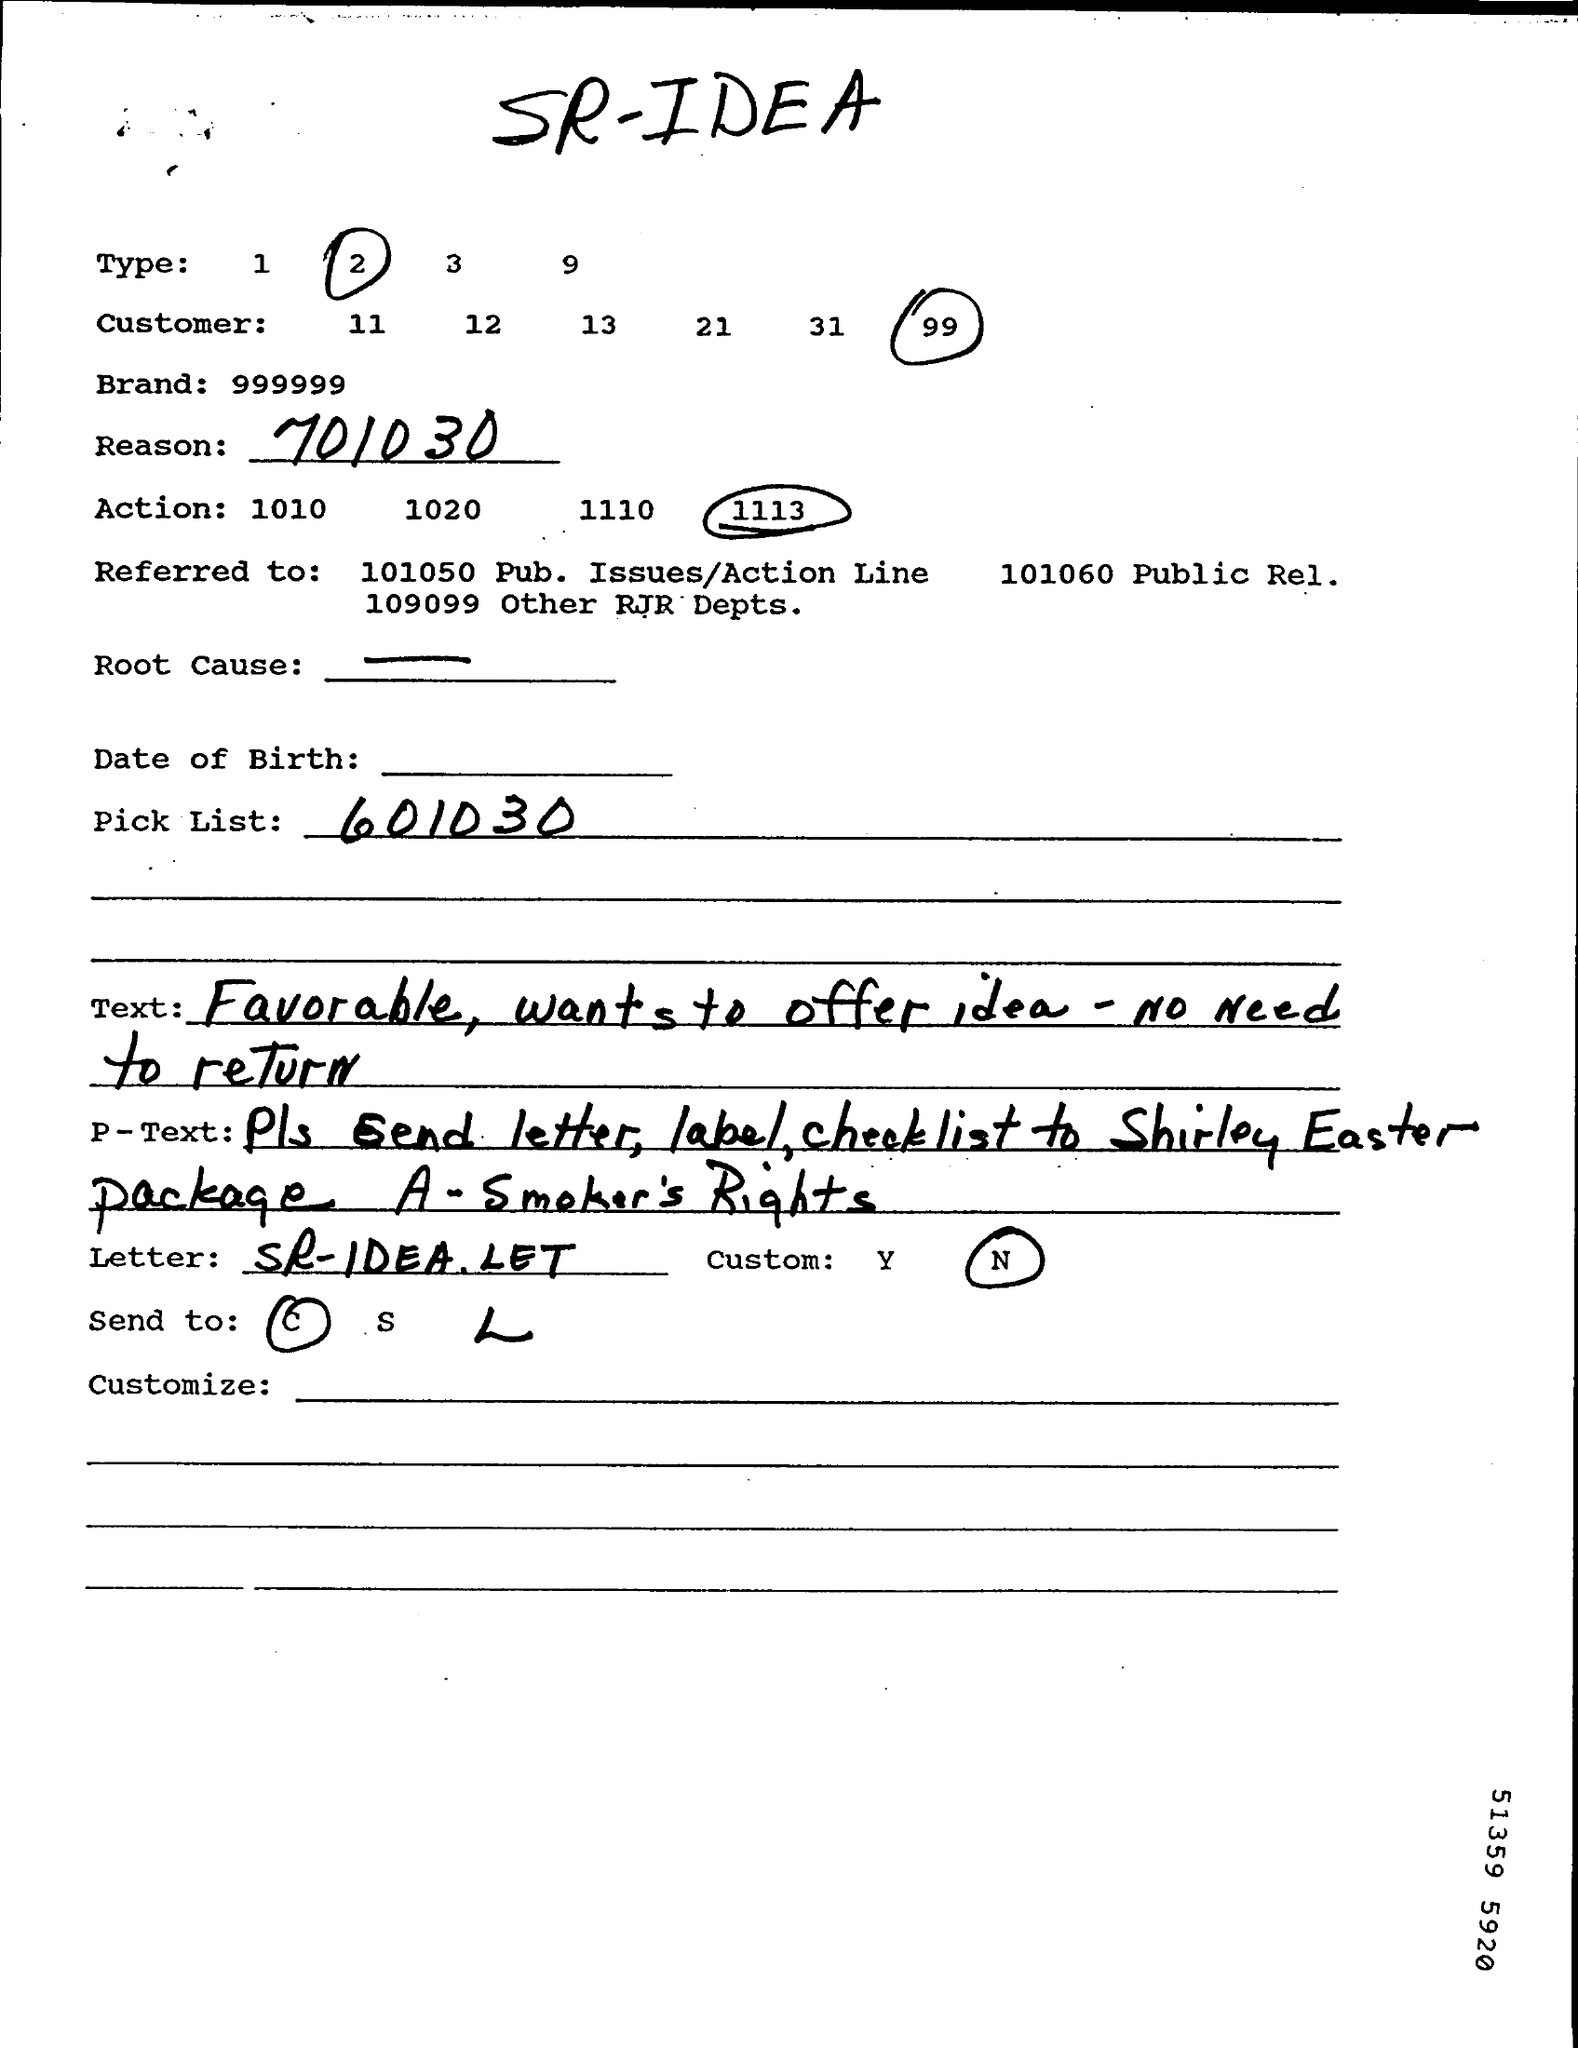Mention a couple of crucial points in this snapshot. The brand is a unique, nine-digit number that serves as a representation of the company's identity and values. The Pick List is a numerical sequence that consists of 601030. 